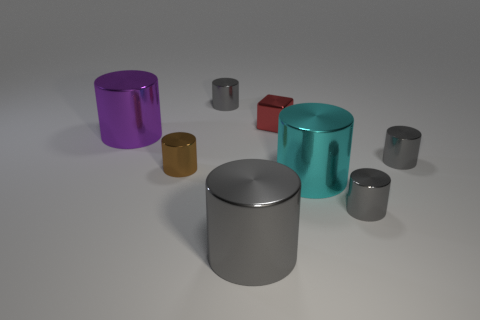Are there any purple matte spheres that have the same size as the metallic block?
Provide a succinct answer. No. Do the large cyan thing and the tiny brown cylinder left of the red shiny block have the same material?
Provide a short and direct response. Yes. Is the number of big gray things greater than the number of large metallic blocks?
Keep it short and to the point. Yes. How many cylinders are small red shiny objects or cyan things?
Ensure brevity in your answer.  1. What color is the small cube?
Provide a short and direct response. Red. There is a brown object that is left of the large cyan metallic cylinder; is its size the same as the gray object behind the tiny red cube?
Your answer should be very brief. Yes. Is the number of big purple cylinders less than the number of small gray cylinders?
Your answer should be compact. Yes. There is a small block; what number of small objects are to the right of it?
Ensure brevity in your answer.  2. What is the material of the large purple thing?
Give a very brief answer. Metal. Are there fewer small brown metal things that are to the left of the small brown thing than small blue things?
Keep it short and to the point. No. 